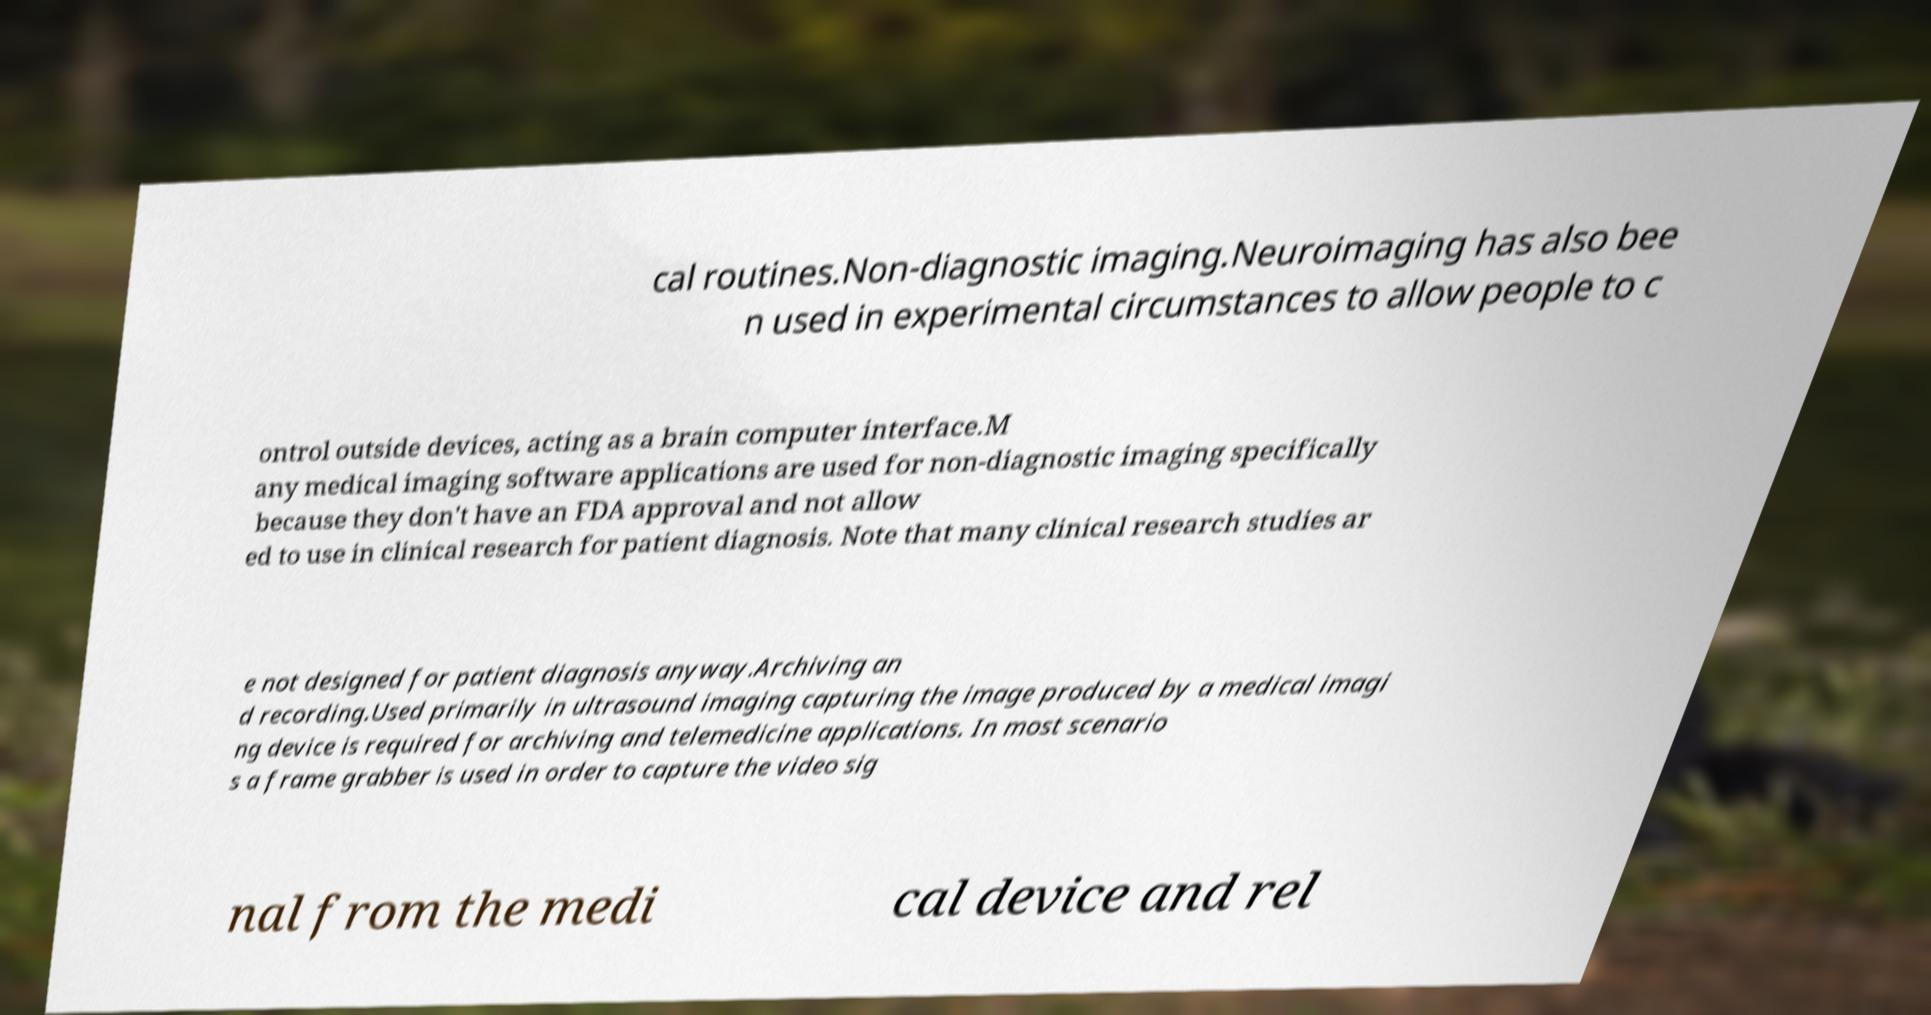Could you assist in decoding the text presented in this image and type it out clearly? cal routines.Non-diagnostic imaging.Neuroimaging has also bee n used in experimental circumstances to allow people to c ontrol outside devices, acting as a brain computer interface.M any medical imaging software applications are used for non-diagnostic imaging specifically because they don't have an FDA approval and not allow ed to use in clinical research for patient diagnosis. Note that many clinical research studies ar e not designed for patient diagnosis anyway.Archiving an d recording.Used primarily in ultrasound imaging capturing the image produced by a medical imagi ng device is required for archiving and telemedicine applications. In most scenario s a frame grabber is used in order to capture the video sig nal from the medi cal device and rel 